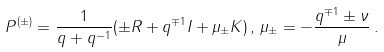Convert formula to latex. <formula><loc_0><loc_0><loc_500><loc_500>P ^ { ( \pm ) } = \frac { 1 } { q + q ^ { - 1 } } ( \pm R + q ^ { \mp 1 } I + \mu _ { \pm } K ) \, , \, \mu _ { \pm } = - \frac { q ^ { \mp 1 } \pm \nu } { \mu } \, .</formula> 